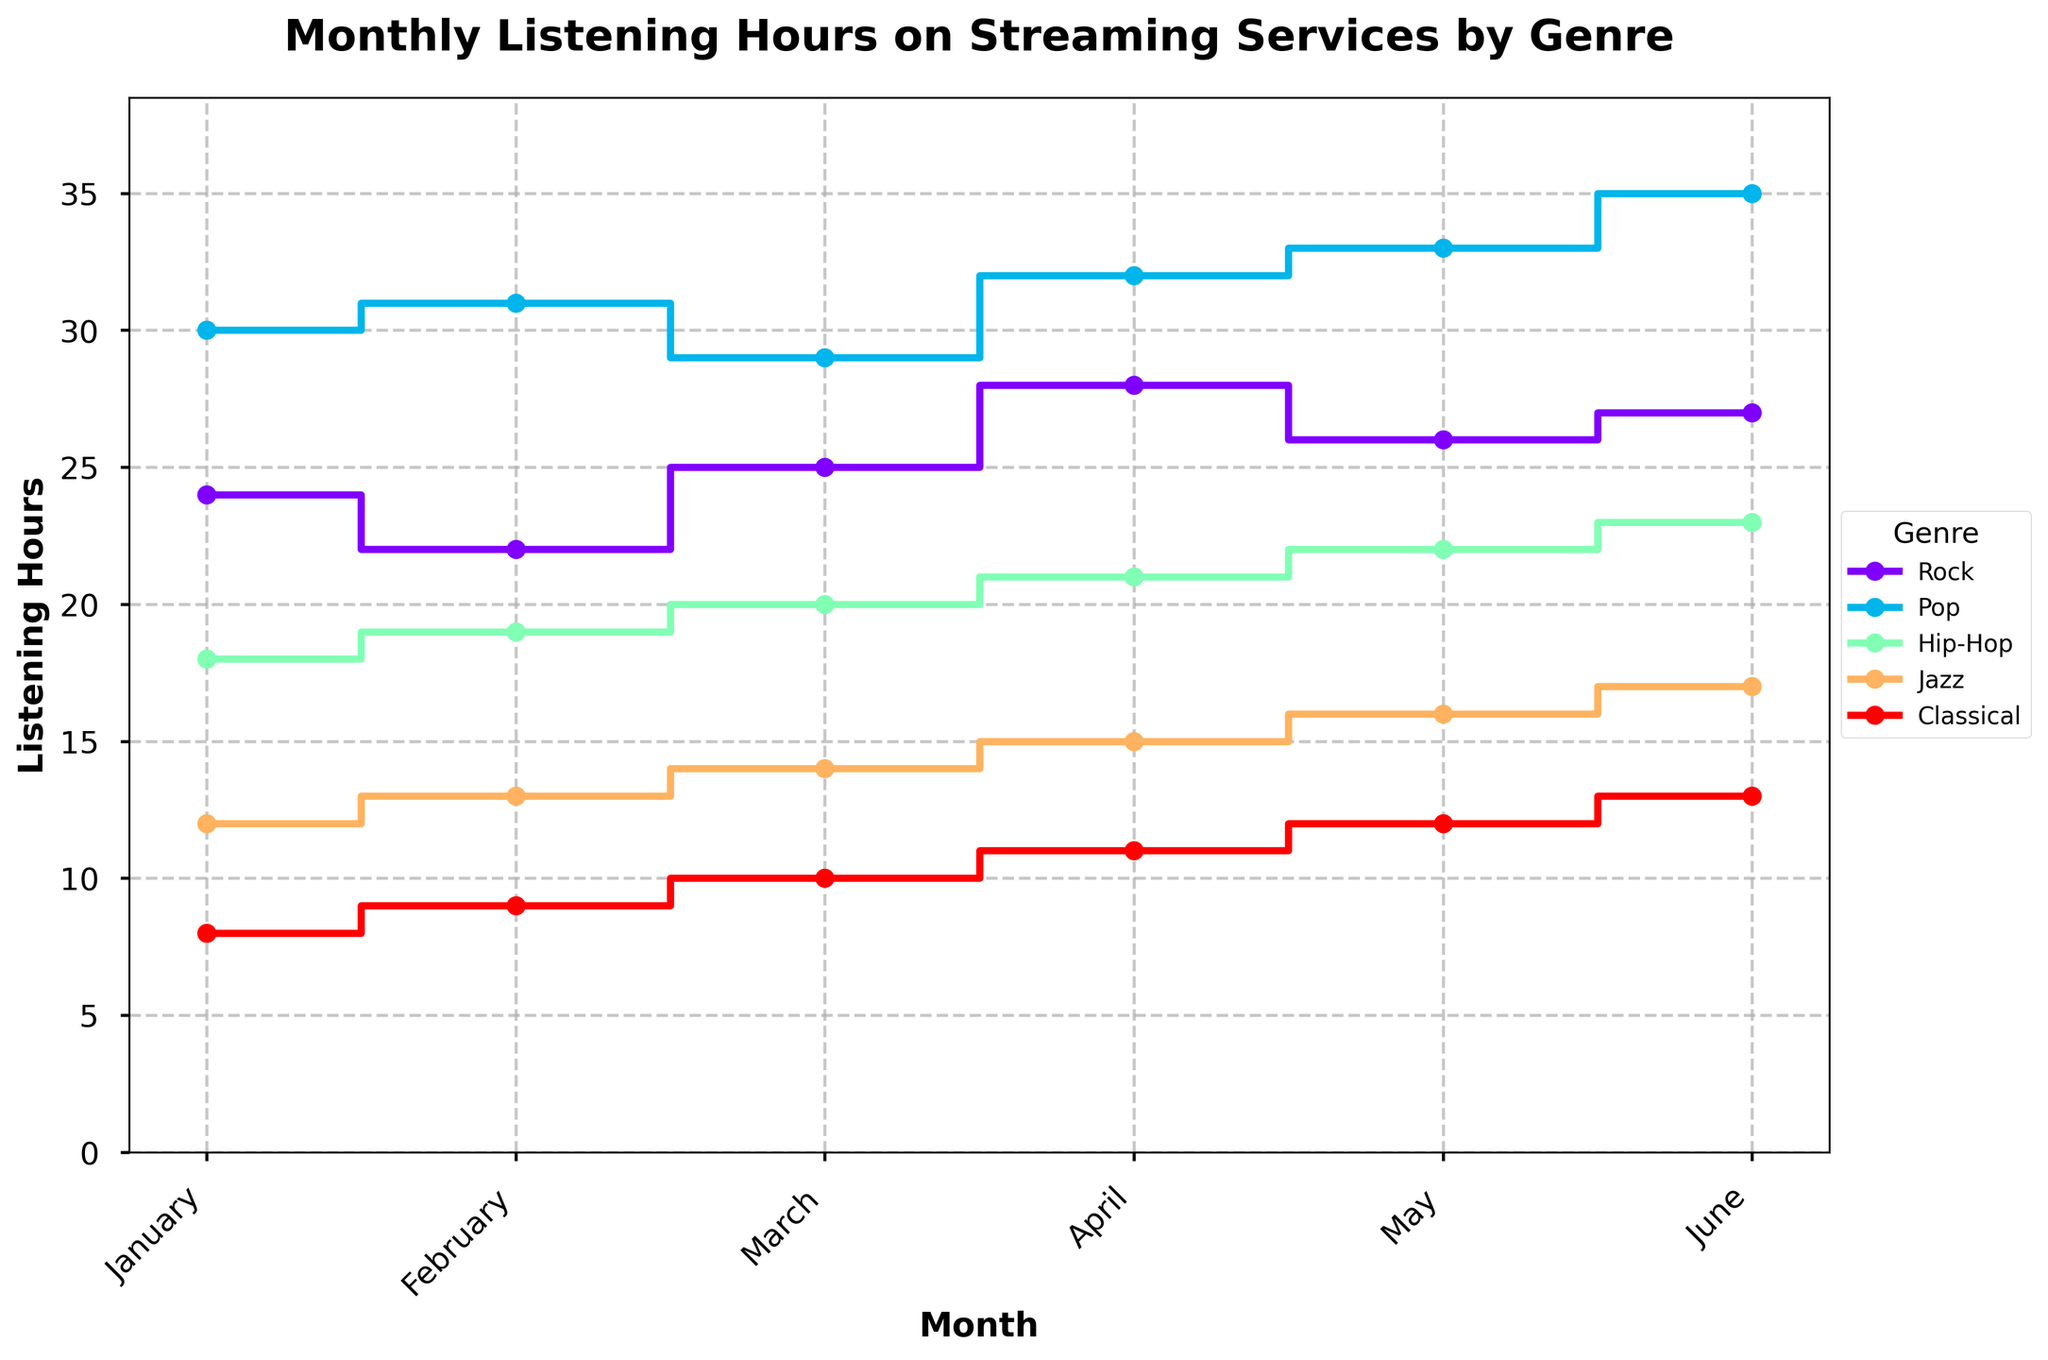what is the title of the plot? The title is located at the top of the figure, generally larger and bolder compared to other text. Here, it clearly says "Monthly Listening Hours on Streaming Services by Genre".
Answer: Monthly Listening Hours on Streaming Services by Genre Which genre had the most listening hours in June? To determine the genre with the most listening hours in June, look for June on the x-axis and identify the highest point on the y-axis. Pop has the highest listening hours with a value of 35.
Answer: Pop How many genres are displayed in the plot? The plot legend shows the different genres represented. There are five genres listed: Rock, Pop, Hip-Hop, Jazz, and Classical.
Answer: 5 Which genre experienced the most consistent listening hours, and why? Consistency can be assessed by observing the fluctuation in the step plot. The genre with the least variation in listening hours across months is Classical, as it only increases by 1 hour each month without major changes.
Answer: Classical What is the difference in listening hours between Rock and Pop in April? First, find the listening hours for Rock and Pop in April on the x-axis. Rock has 28 hours and Pop has 32. The difference is 32 - 28 = 4 hours.
Answer: 4 Which two genres had the smallest difference in listening hours in March, and what is that difference? Find the listening hours of all genres in March. In March, Rock has 25, Pop has 29, Hip-Hop has 20, Jazz has 14, and Classical has 10. The smallest difference is between Hip-Hop and Jazz, which is 20 - 14 = 6 hours.
Answer: Hip-Hop and Jazz, 6 What was the total listening hours for Jazz across all months shown? Sum the listening hours for Jazz from January to June: 12 + 13 + 14 + 15 + 16 + 17 = 87 hours.
Answer: 87 Compared to January, how much did the listening hours for Hip-Hop increase in June? In January, Hip-Hop has 18 hours and in June it has 23 hours. The increase is 23 - 18 = 5 hours.
Answer: 5 How does the trend of listening hours for Pop compare to that of Classical from January to June? For Pop, the listening hours increase steadily from 30 to 35. For Classical, the hours increase more gradually from 8 to 13, both showing an upward trend but Pop has higher hours and steeper increase.
Answer: Both are upward trends; Pop increases more rapidly 